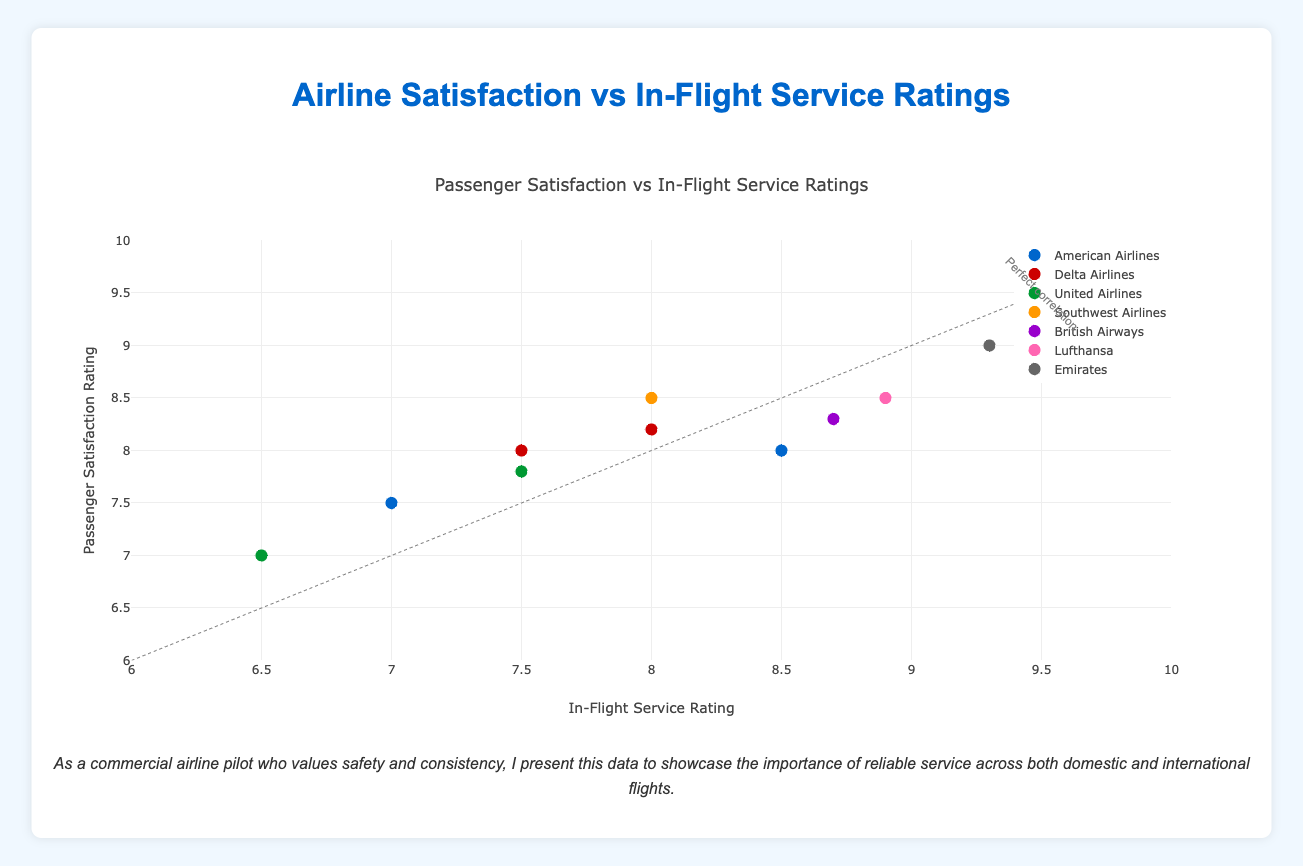What is the title of the figure? The title of the figure is found at the top center and directly describes the content of the figure.
Answer: Airline Satisfaction vs In-Flight Service Ratings How many airlines are represented in the plot? Each airline has a unique color and is listed in the legend on the right side of the plot. Counting the unique colors gives the number of airlines.
Answer: 7 Which airline has the highest passenger satisfaction rating? The point with the highest passenger satisfaction rating on the y-axis belongs to Emirates. This is confirmed by the legend showing the color and symbol associated with Emirates.
Answer: Emirates Which airline has the lowest in-flight service rating? The point with the lowest in-flight service rating on the x-axis belongs to United Airlines. This is confirmed by the legend showing the color and symbol associated with United Airlines.
Answer: United Airlines What is the range of passenger satisfaction ratings for domestic flights? The passenger satisfaction ratings for domestic flights are represented by circles. Identifying the minimum and maximum y-values of these points gives the range. Southwest Airlines (8.5) has the highest, and United Airlines (7.0) has the lowest.
Answer: 7.0 to 8.5 Which airline shows the highest discrepancy between domestic and international passenger satisfaction ratings? By comparing the y-values for each airline, American Airlines has a significant jump from 7.5 (domestic) to 8.0 (international).
Answer: American Airlines Is there a general trend between in-flight service ratings and passenger satisfaction ratings? The plot includes a grey line indicating perfect correlation between the two ratings, and most points are close to this line. Thus, there is generally a positive correlation between in-flight service and passenger satisfaction ratings.
Answer: Yes For Delta Airlines, is the international in-flight service rating greater than the domestic in-flight service rating? By comparing the x-values for Delta Airlines, 8.0 (international) is greater than 7.5 (domestic).
Answer: Yes What is the in-flight service rating of Southwest Airlines? Southwest Airlines is represented by a specific color in the legend, and the x-axis value of the Southwest Airlines data point is 8.0.
Answer: 8.0 How does the in-flight service rating of Lufthansa compare to that of Emirates? Lufthansa's in-flight service rating is 8.9, while Emirates' is 9.3, as indicated by their respective points on the x-axis.
Answer: Lufthansa's is lower than Emirates' 